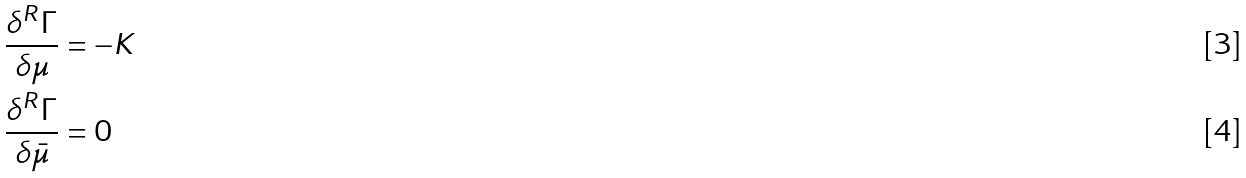Convert formula to latex. <formula><loc_0><loc_0><loc_500><loc_500>\frac { \delta ^ { R } \Gamma } { \delta \mu } & = - K \\ \frac { \delta ^ { R } \Gamma } { \delta \bar { \mu } } & = 0</formula> 